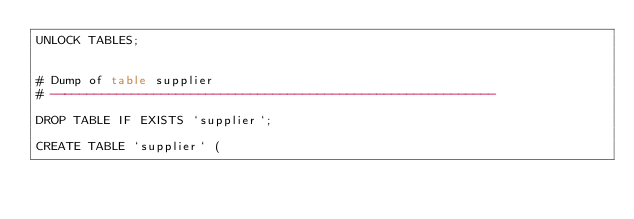Convert code to text. <code><loc_0><loc_0><loc_500><loc_500><_SQL_>UNLOCK TABLES;


# Dump of table supplier
# ------------------------------------------------------------

DROP TABLE IF EXISTS `supplier`;

CREATE TABLE `supplier` (</code> 